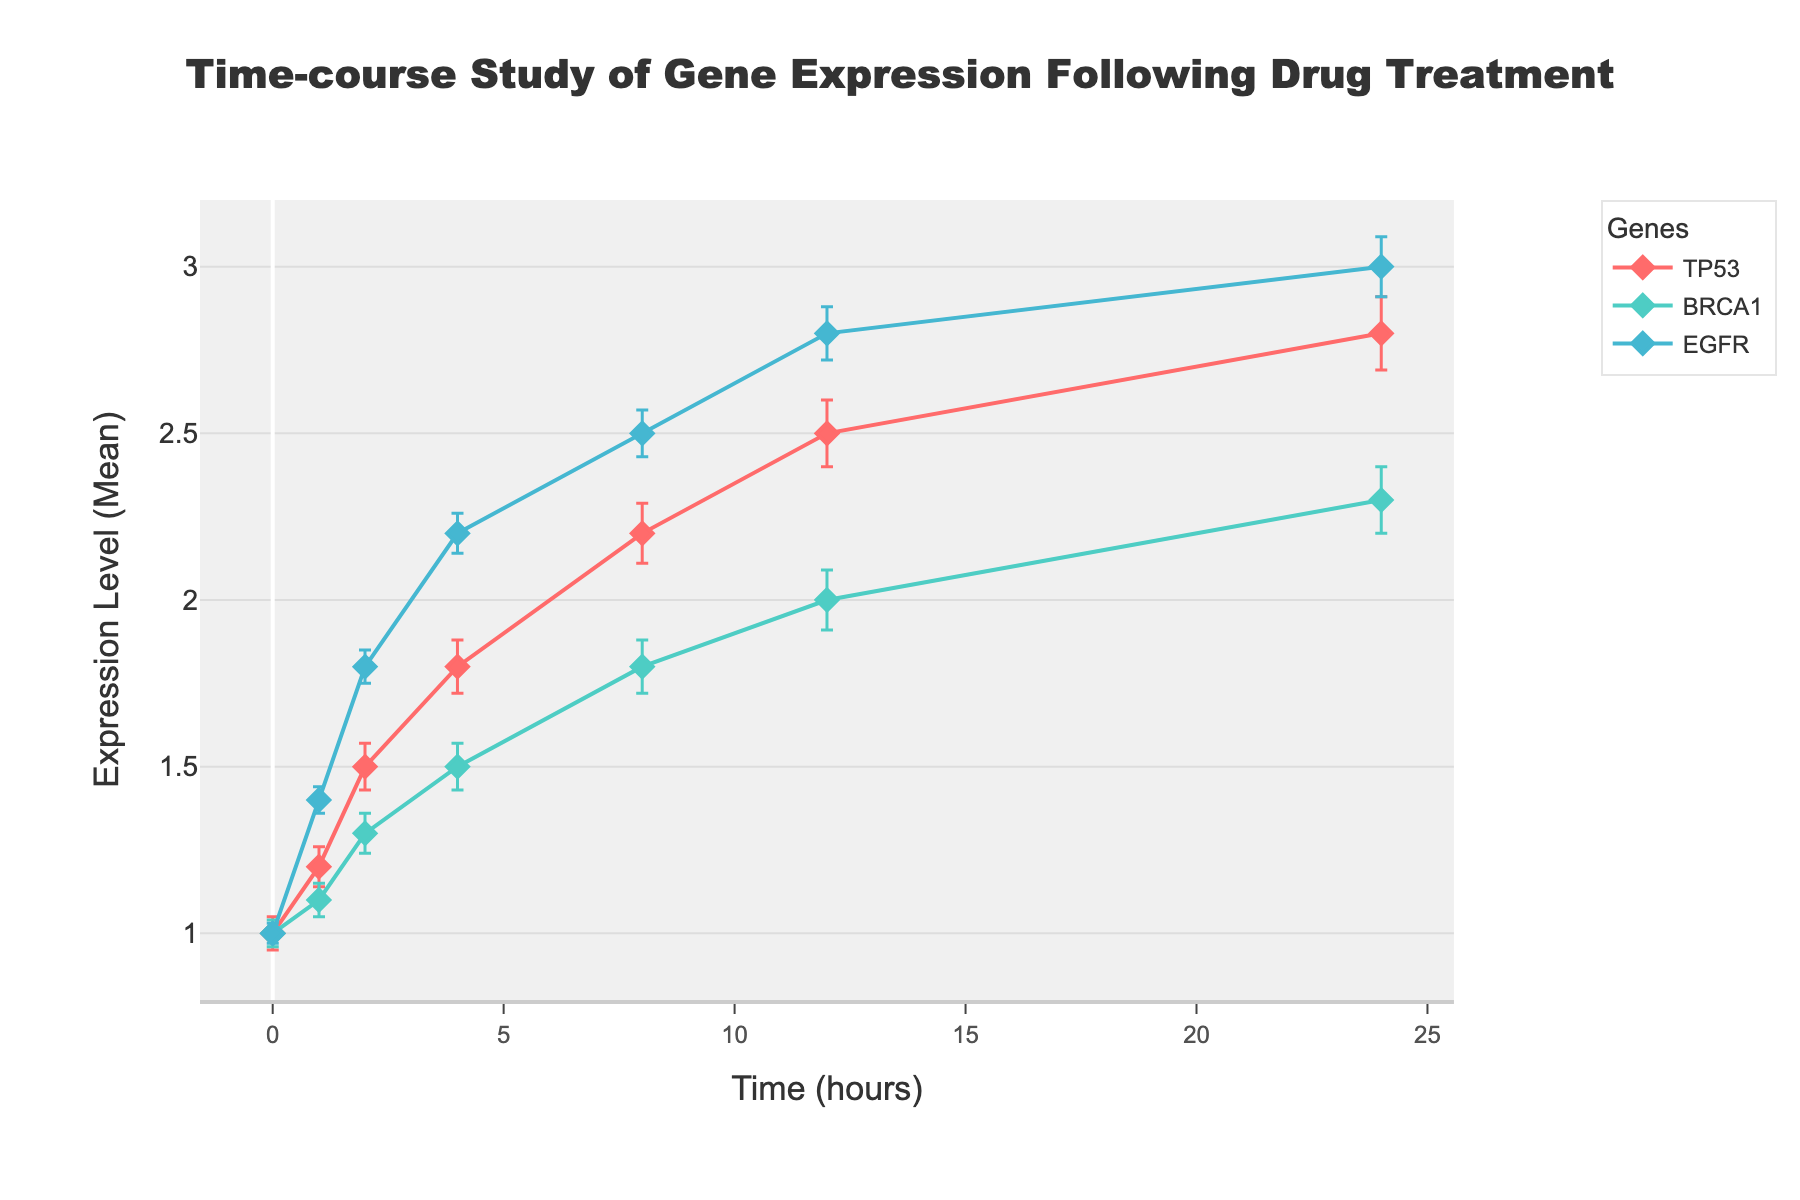What is the title of the figure? The title of the figure is located at the top of the graph. It usually gives a brief description of what the figure represents. In this case, the title is "Time-course Study of Gene Expression Following Drug Treatment".
Answer: Time-course Study of Gene Expression Following Drug Treatment What information is represented on the x-axis? The x-axis of the graph provides information about the progression of time. In this figure, the x-axis is labeled "Time (hours)", indicating that it shows the time in hours following drug treatment.
Answer: Time (hours) How many genes are represented in the figure? To determine the number of genes shown, look at the legend or the different lines in the plot. Each gene is represented by a unique color and label. In this case, three genes are shown: TP53, BRCA1, and EGFR.
Answer: Three Which gene shows the highest expression level at 8 hours? To answer this, locate the data points at the 8-hour mark on the x-axis. Then, compare the y-values (expression levels) of the three genes. The highest point among them indicates the gene with the highest expression.
Answer: EGFR What is the expression level of TP53 at 24 hours? Find the time point of 24 hours on the x-axis and track the corresponding y-value for the TP53 gene. This will indicate the expression level of TP53 at that time.
Answer: 2.8 Which gene shows the smallest change in expression level from 0 hours to 24 hours? Calculate the change in expression for each gene by subtracting their expression level at 0 hours from their expression level at 24 hours. Compare these values to determine which gene has the smallest change.
Answer: BRCA1 What is the range of the y-axis? The range of the y-axis is determined by the lowest and highest values displayed on the y-axis. In this figure, the y-axis starts at 0.8 and ends at 3.2.
Answer: 0.8 to 3.2 How do the error bars for TP53 at 1 hour compare to those for EGFR at 2 hours? Locate the error bars for TP53 at 1 hour and for EGFR at 2 hours. Compare the lengths of the error bars to determine which one is larger. Error bars represent the standard error.
Answer: EGFR at 2 hours has longer error bars What is the trend in expression for BRCA1 over the 24 hours? Look at the data points for BRCA1 from 0 hours to 24 hours. Identify whether the expression levels are increasing, decreasing, or staying constant over time. In this case, BRCA1 expression is gradually increasing.
Answer: Increasing Which gene has the most significant increase in expression between 0 hours and 8 hours? Calculate the increase in expression for each gene between 0 hours and 8 hours by subtracting the expression level at 0 hours from the expression level at 8 hours. Compare these increases to determine the most significant one.
Answer: EGFR 